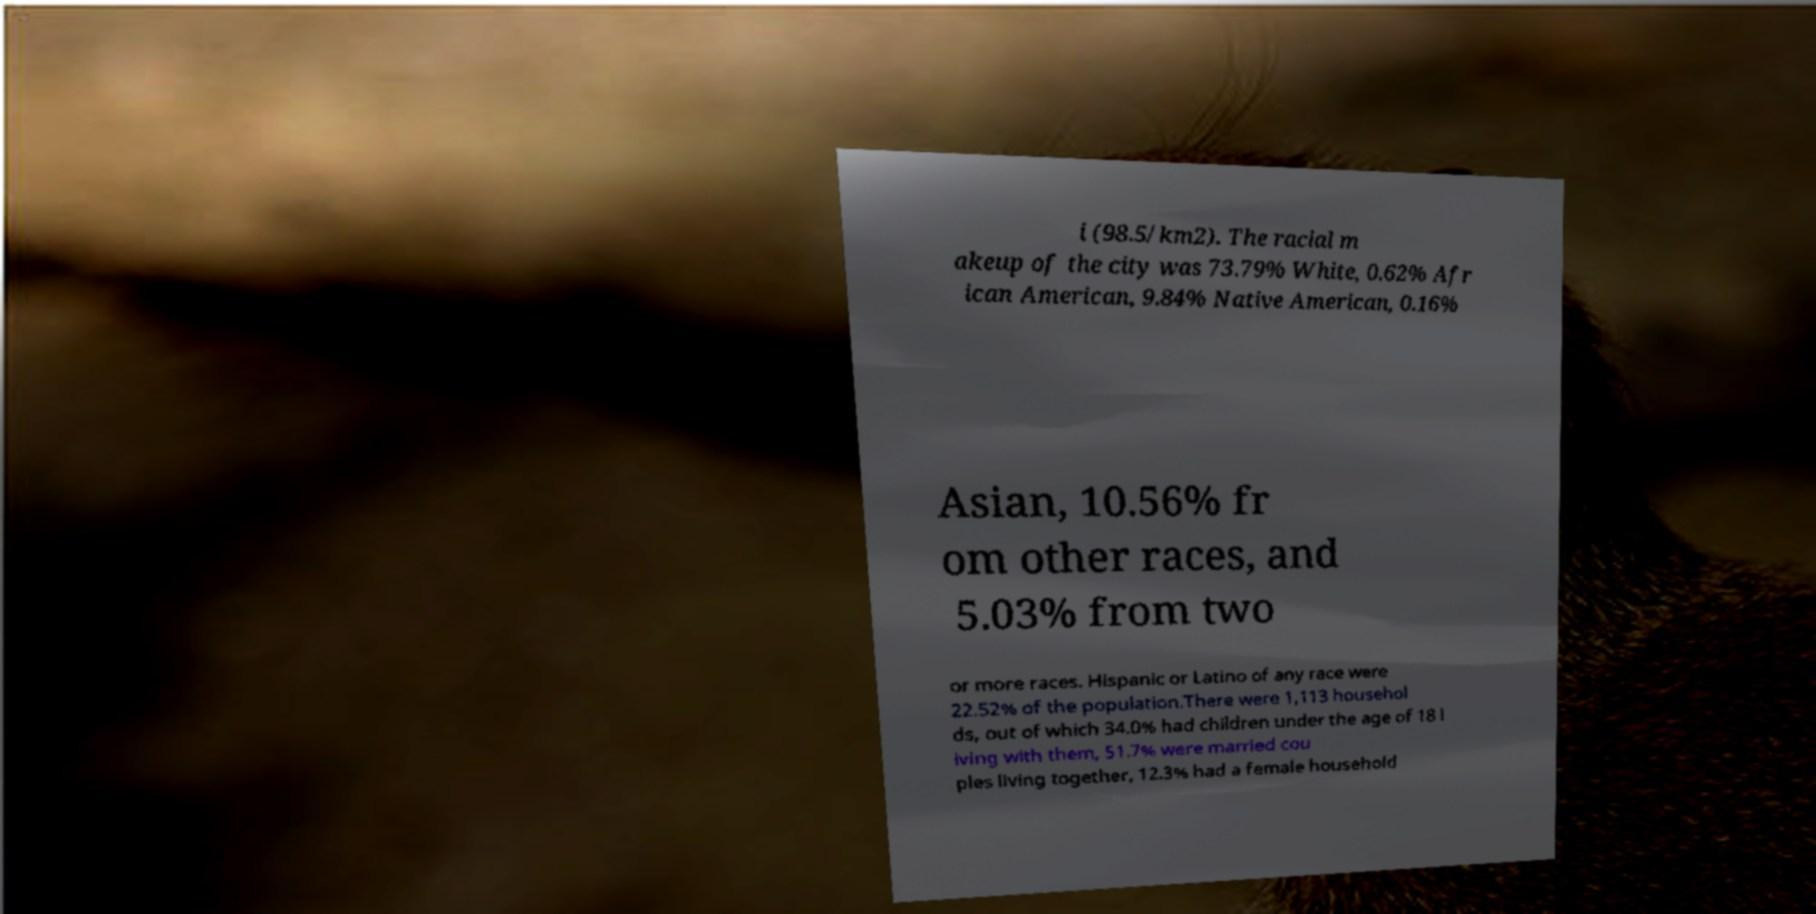For documentation purposes, I need the text within this image transcribed. Could you provide that? i (98.5/km2). The racial m akeup of the city was 73.79% White, 0.62% Afr ican American, 9.84% Native American, 0.16% Asian, 10.56% fr om other races, and 5.03% from two or more races. Hispanic or Latino of any race were 22.52% of the population.There were 1,113 househol ds, out of which 34.0% had children under the age of 18 l iving with them, 51.7% were married cou ples living together, 12.3% had a female household 